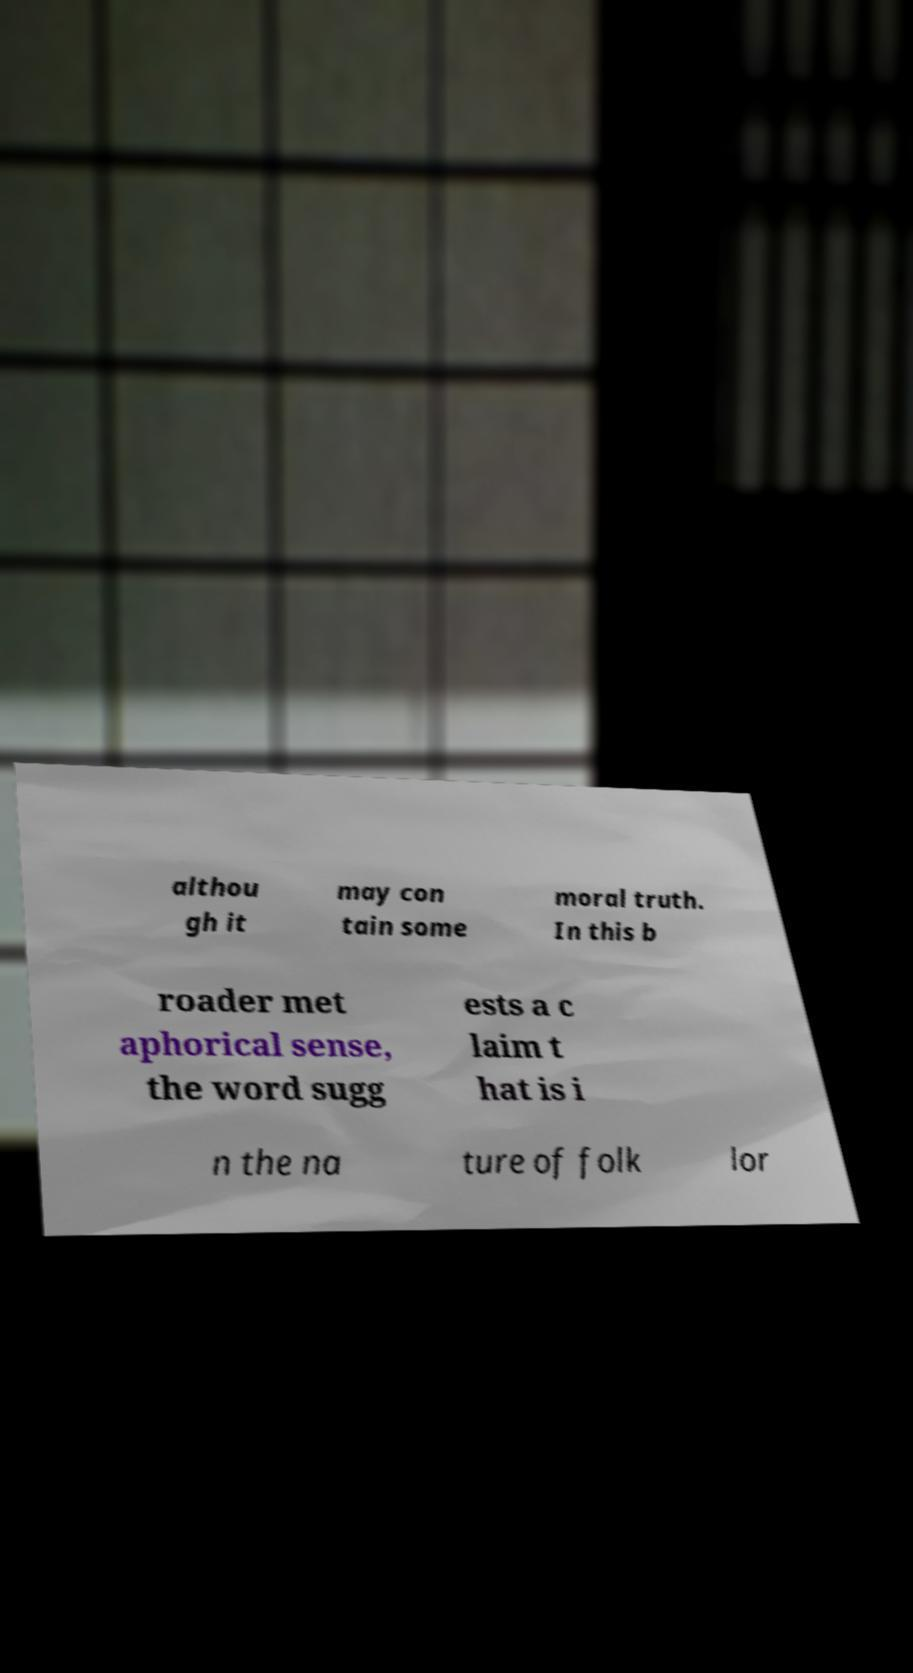Can you read and provide the text displayed in the image?This photo seems to have some interesting text. Can you extract and type it out for me? althou gh it may con tain some moral truth. In this b roader met aphorical sense, the word sugg ests a c laim t hat is i n the na ture of folk lor 